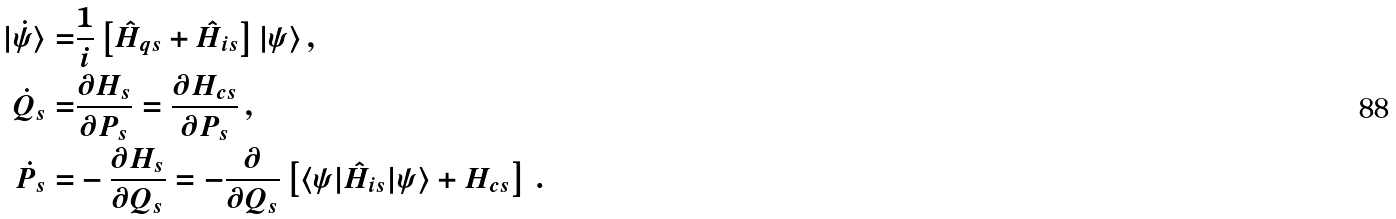Convert formula to latex. <formula><loc_0><loc_0><loc_500><loc_500>| \dot { \psi } \rangle = & \frac { 1 } { i } \left [ \hat { H } _ { q s } + \hat { H } _ { i s } \right ] | \psi \rangle \, , \\ \dot { Q } _ { s } = & \frac { \partial H _ { s } } { \partial P _ { s } } = \frac { \partial H _ { c s } } { \partial P _ { s } } \, , \\ \dot { P } _ { s } = & - \frac { \partial H _ { s } } { \partial Q _ { s } } = - \frac { \partial } { \partial Q _ { s } } \left [ \langle \psi | \hat { H } _ { i s } | \psi \rangle + H _ { c s } \right ] \, .</formula> 